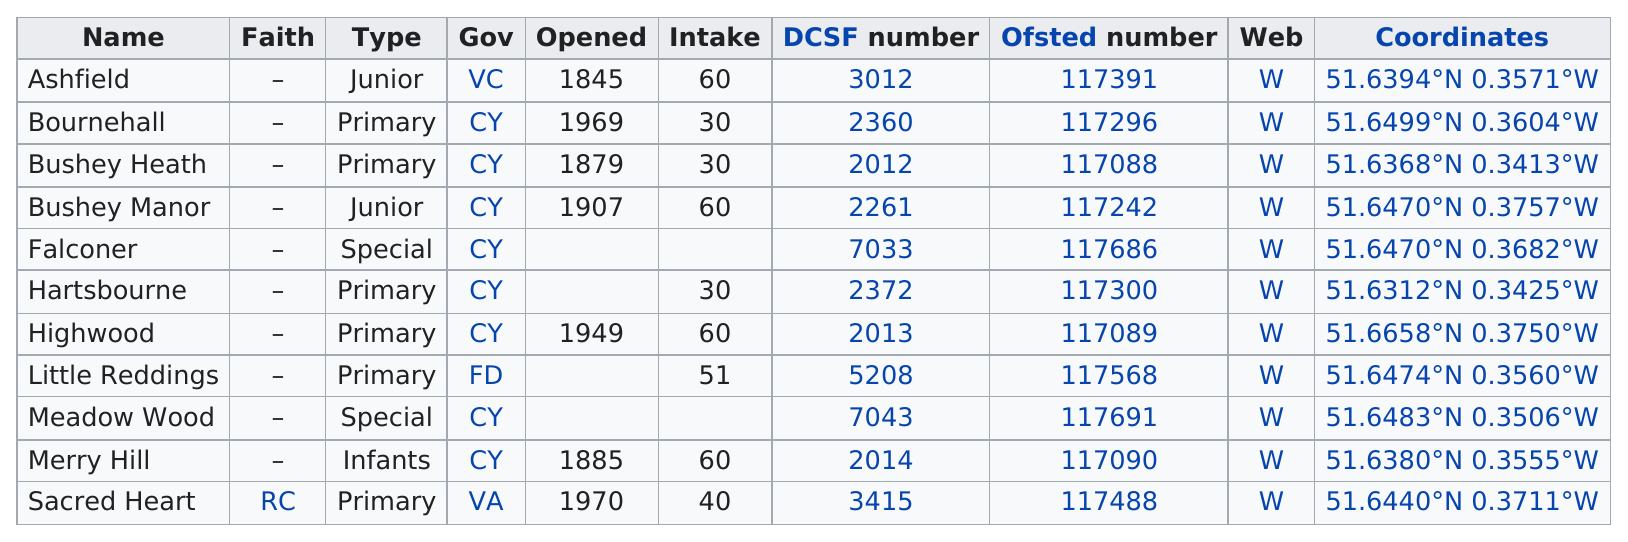List a handful of essential elements in this visual. In the United States, how many schools have an enrollment of at least 50 students? The name that comes before Bournehall Health is Bushey. There are five schools that have a greater number of students than Sacred Heart. At least four types exist. The following schools are not primary schools: Ashfield, Bushey Manor, Falconer, Meadow Wood, and Merry Hill. 